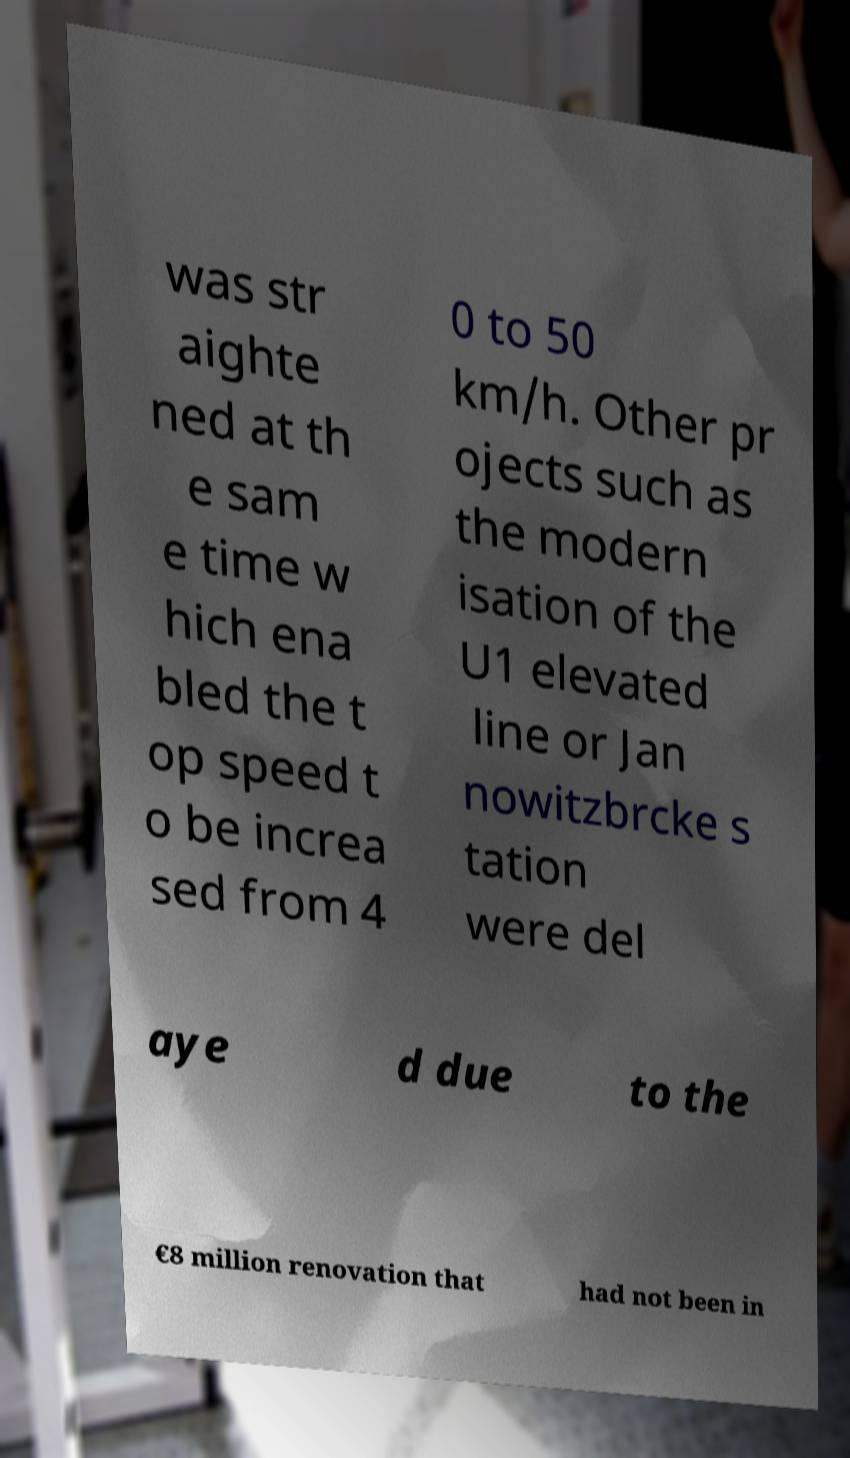Please identify and transcribe the text found in this image. was str aighte ned at th e sam e time w hich ena bled the t op speed t o be increa sed from 4 0 to 50 km/h. Other pr ojects such as the modern isation of the U1 elevated line or Jan nowitzbrcke s tation were del aye d due to the €8 million renovation that had not been in 